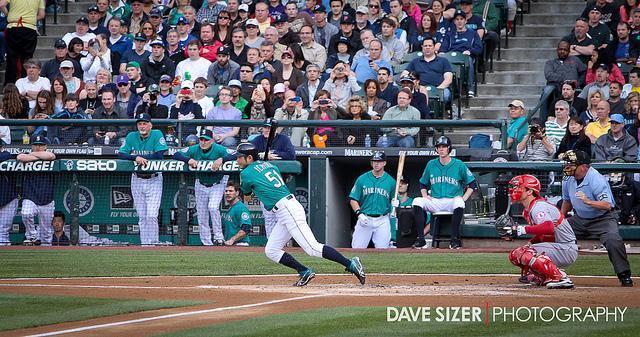How many people are in the photo?
Give a very brief answer. 5. How many horses are there?
Give a very brief answer. 0. 